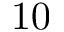Convert formula to latex. <formula><loc_0><loc_0><loc_500><loc_500>1 0</formula> 